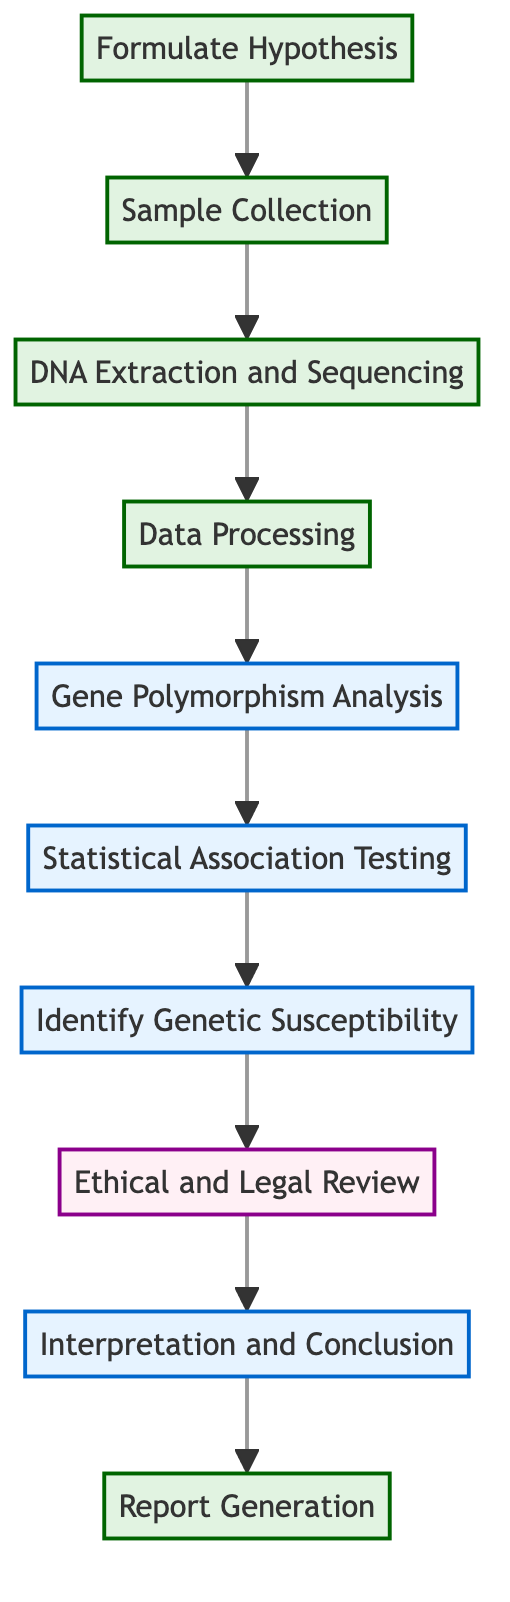What is the first step in the decision process? The diagram indicates that the first step is "Formulate Hypothesis," as it is the starting point of the flow.
Answer: Formulate Hypothesis How many nodes are present in the diagram? Counting each block in the diagram, there are a total of ten distinct nodes shown.
Answer: Ten What follows after "Statistical Association Testing"? In the flow of the diagram, the step following "Statistical Association Testing" is "Identify Genetic Susceptibility."
Answer: Identify Genetic Susceptibility What type of review is included in the process? The diagram includes an "Ethical and Legal Review," which is explicitly indicated within the steps of the process.
Answer: Ethical and Legal Review Which step focuses on reporting findings? The last node in the diagram is "Report Generation," which is designated for documenting and reporting findings.
Answer: Report Generation What is the relationship between "DNA Extraction and Sequencing" and "Data Processing"? The diagram shows a direct link from "DNA Extraction and Sequencing" to "Data Processing," indicating that data processing comes immediately after sequencing.
Answer: Direct link Which step comes before the "Interpretation and Conclusion"? The diagram shows that "Ethical and Legal Review" is the step that precedes "Interpretation and Conclusion" in the process flow.
Answer: Ethical and Legal Review How many analysis-related steps are there in this process? There are three analysis-related steps shown, which are "Gene Polymorphism Analysis," "Statistical Association Testing," and "Identify Genetic Susceptibility."
Answer: Three What is the concluding step of this block diagram? The final node listed in the diagram is "Report Generation," which signifies the conclusion of the process.
Answer: Report Generation 